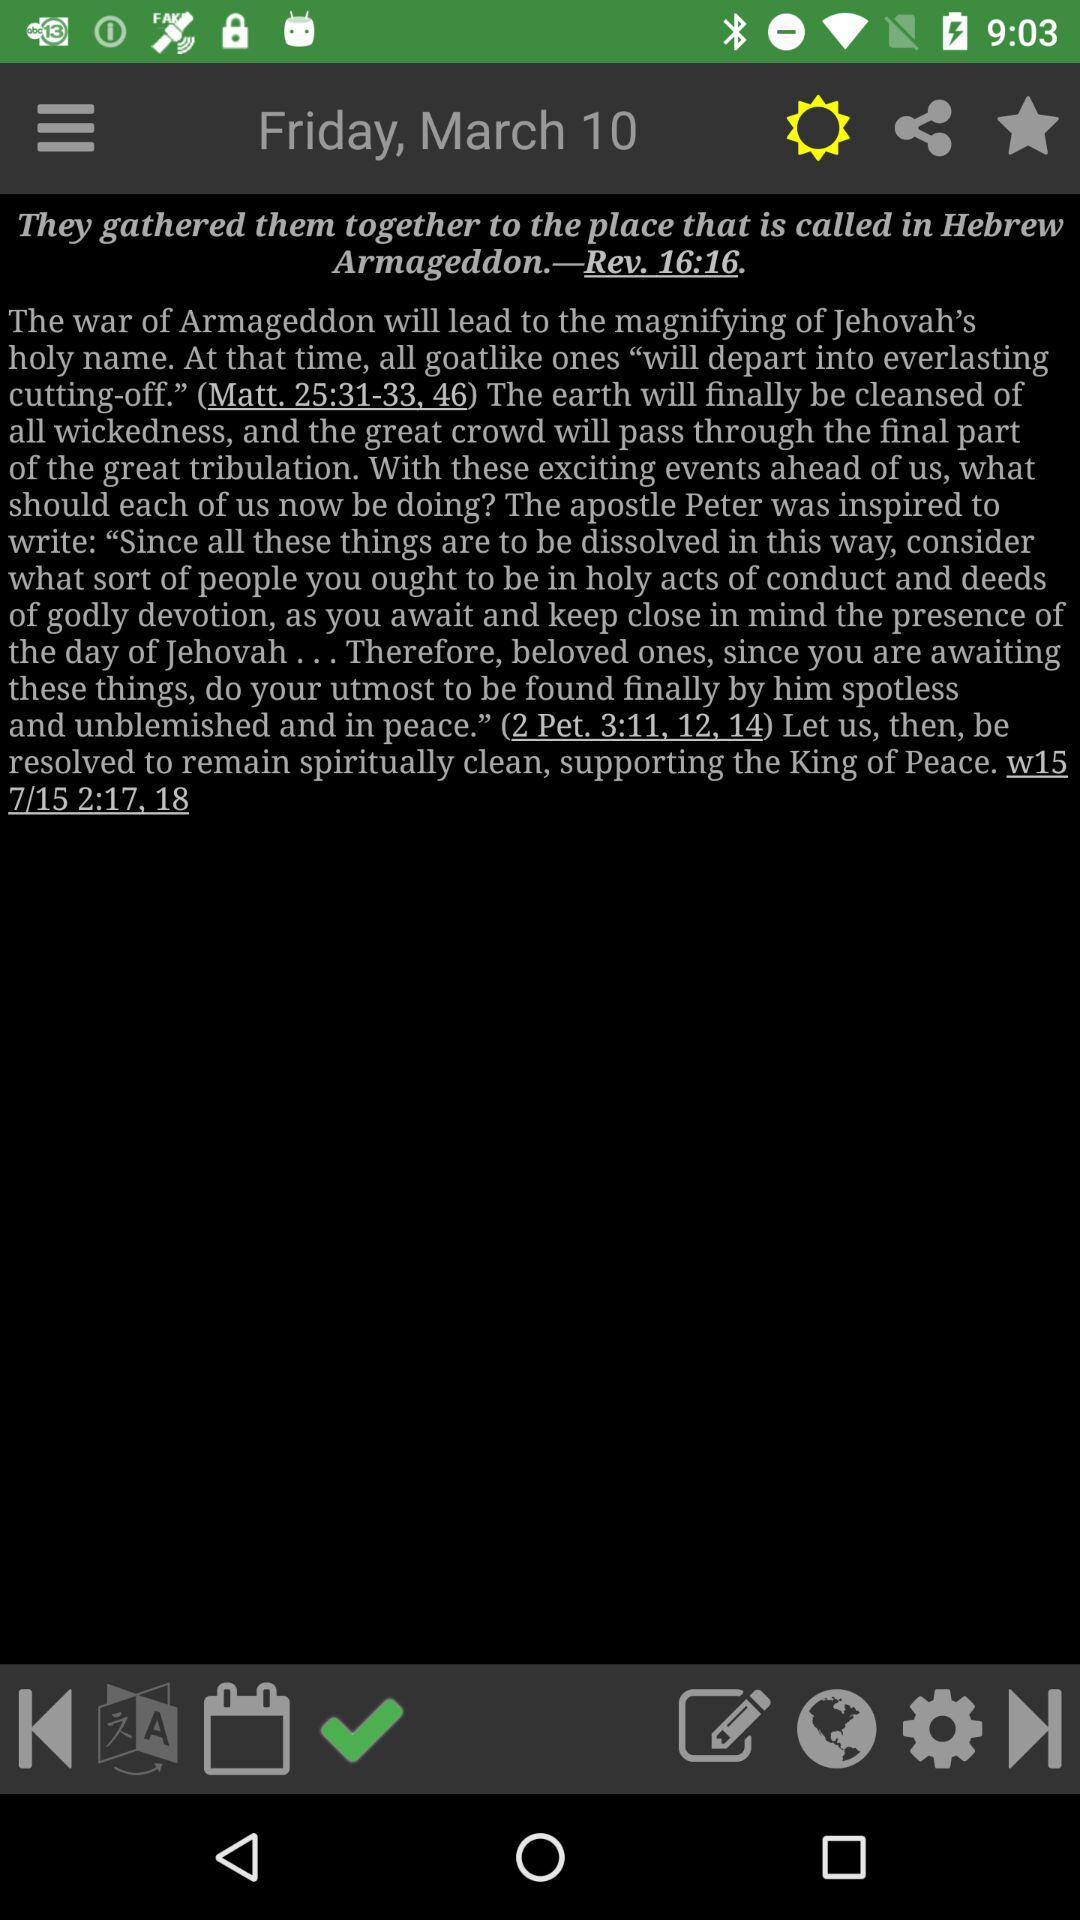What is the date when the article was published? The article was published on Friday, March 10. 